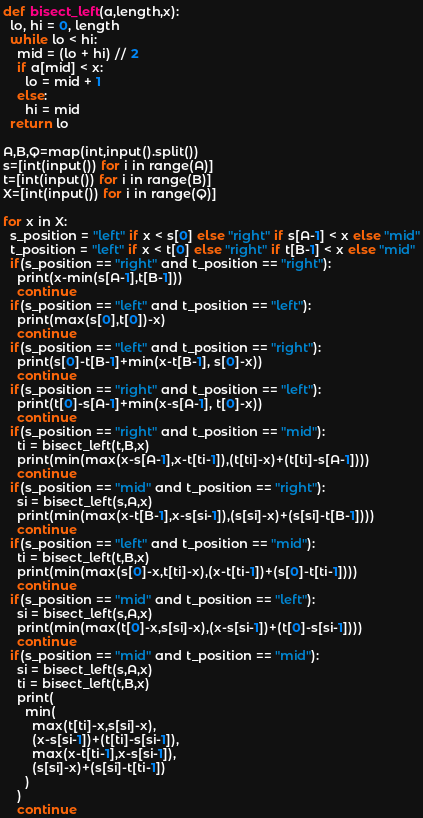<code> <loc_0><loc_0><loc_500><loc_500><_Python_>def bisect_left(a,length,x):
  lo, hi = 0, length
  while lo < hi:
    mid = (lo + hi) // 2
    if a[mid] < x:
      lo = mid + 1
    else:
      hi = mid
  return lo

A,B,Q=map(int,input().split())
s=[int(input()) for i in range(A)]
t=[int(input()) for i in range(B)]
X=[int(input()) for i in range(Q)]

for x in X:
  s_position = "left" if x < s[0] else "right" if s[A-1] < x else "mid"
  t_position = "left" if x < t[0] else "right" if t[B-1] < x else "mid"
  if(s_position == "right" and t_position == "right"):
    print(x-min(s[A-1],t[B-1]))
    continue
  if(s_position == "left" and t_position == "left"):
    print(max(s[0],t[0])-x)
    continue
  if(s_position == "left" and t_position == "right"):
    print(s[0]-t[B-1]+min(x-t[B-1], s[0]-x))
    continue
  if(s_position == "right" and t_position == "left"):
    print(t[0]-s[A-1]+min(x-s[A-1], t[0]-x))
    continue
  if(s_position == "right" and t_position == "mid"):
    ti = bisect_left(t,B,x)
    print(min(max(x-s[A-1],x-t[ti-1]),(t[ti]-x)+(t[ti]-s[A-1])))
    continue
  if(s_position == "mid" and t_position == "right"):
    si = bisect_left(s,A,x)
    print(min(max(x-t[B-1],x-s[si-1]),(s[si]-x)+(s[si]-t[B-1])))
    continue
  if(s_position == "left" and t_position == "mid"):
    ti = bisect_left(t,B,x)
    print(min(max(s[0]-x,t[ti]-x),(x-t[ti-1])+(s[0]-t[ti-1])))
    continue
  if(s_position == "mid" and t_position == "left"):
    si = bisect_left(s,A,x)
    print(min(max(t[0]-x,s[si]-x),(x-s[si-1])+(t[0]-s[si-1])))
    continue
  if(s_position == "mid" and t_position == "mid"):
    si = bisect_left(s,A,x)
    ti = bisect_left(t,B,x)
    print(
      min(
        max(t[ti]-x,s[si]-x),
        (x-s[si-1])+(t[ti]-s[si-1]),
        max(x-t[ti-1],x-s[si-1]),
        (s[si]-x)+(s[si]-t[ti-1])
      )
    )
    continue</code> 